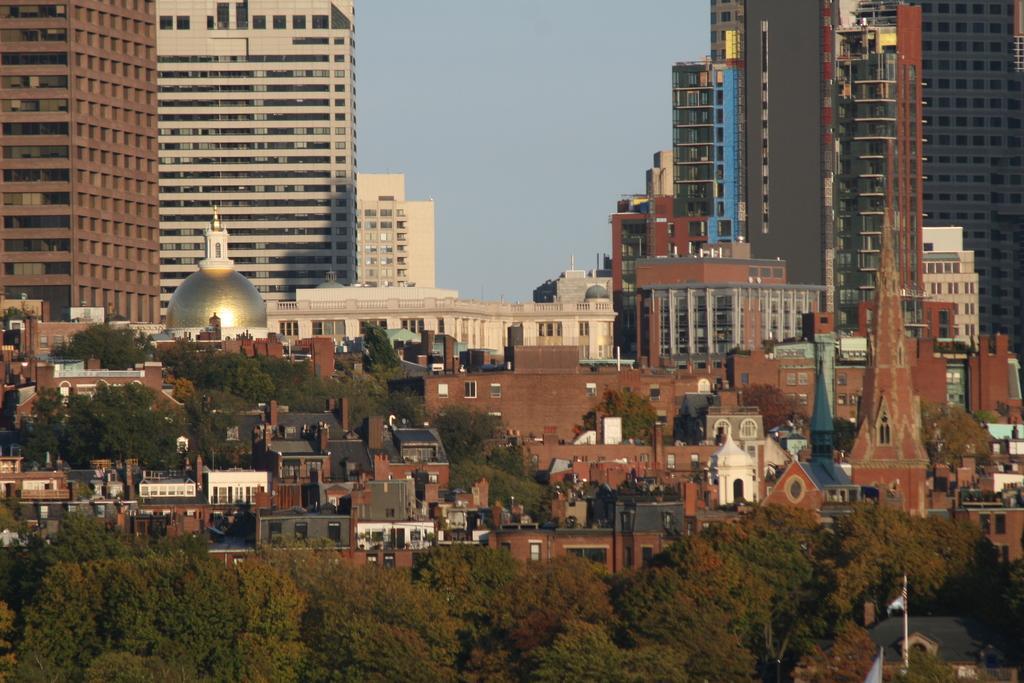Can you describe this image briefly? At the down side these are the green trees and in the middle these are the very big buildings. 